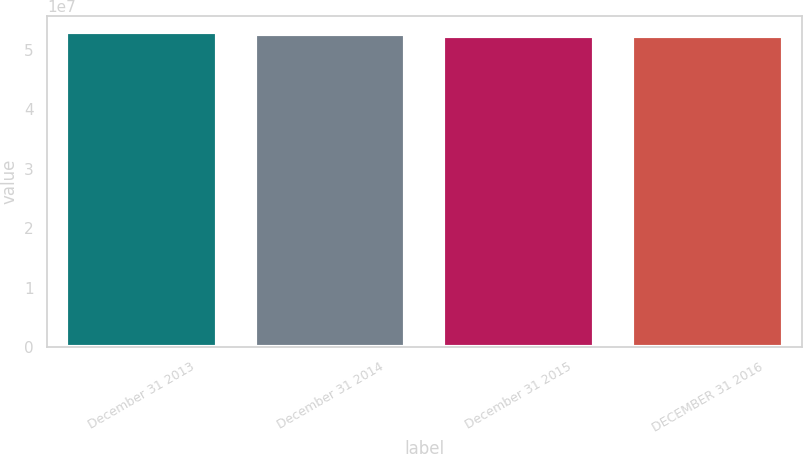Convert chart. <chart><loc_0><loc_0><loc_500><loc_500><bar_chart><fcel>December 31 2013<fcel>December 31 2014<fcel>December 31 2015<fcel>DECEMBER 31 2016<nl><fcel>5.30981e+07<fcel>5.26661e+07<fcel>5.23741e+07<fcel>5.22937e+07<nl></chart> 